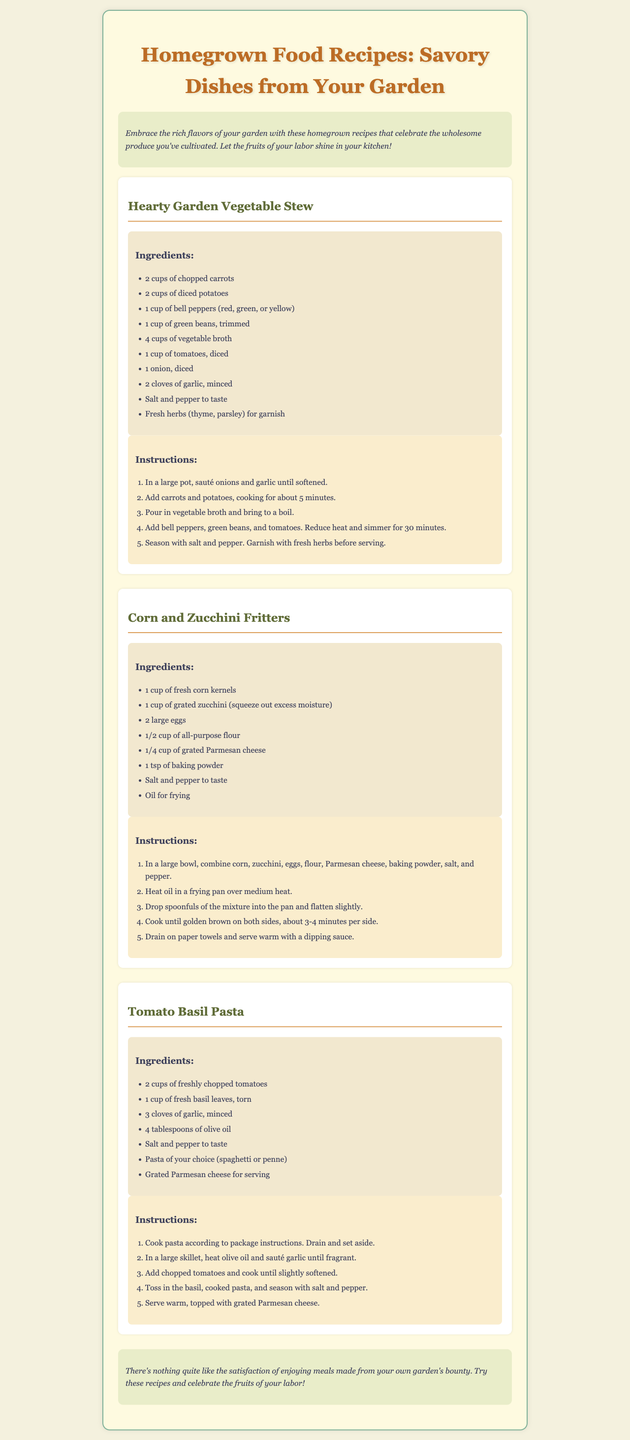What is the title of the brochure? The title is typically displayed prominently at the top of the document.
Answer: Homegrown Food Recipes: Savory Dishes from Your Garden How many recipes are included in the brochure? The recipes can be counted by looking at the distinct recipe sections in the document.
Answer: 3 What is one of the main ingredients in Hearty Garden Vegetable Stew? This can be found in the ingredients list section of the recipe.
Answer: Carrots What cooking method is used for Corn and Zucchini Fritters? The method for preparing this dish can be found in the instructions section of the recipe.
Answer: Frying Which herb is mentioned in Tomato Basil Pasta recipe? This information comes from the ingredients list of that specific recipe.
Answer: Basil What is used for garnishing the Hearty Garden Vegetable Stew? The document mentions garnishing details in the instructions or ingredient section of the recipe.
Answer: Fresh herbs What type of cheese is used in Corn and Zucchini Fritters? The answer is directly from the ingredients listed in the recipe.
Answer: Parmesan cheese In which section can you find cooking instructions for the recipes? Instructions are typically found in a specified part of each recipe section.
Answer: In the instructions section 